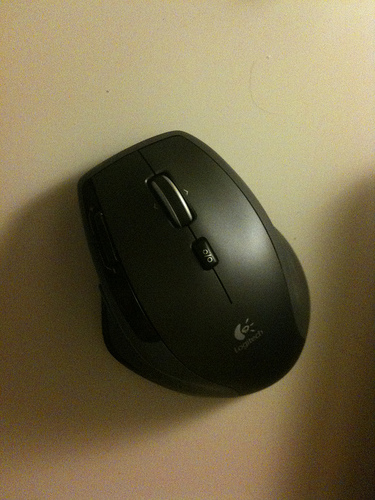<image>
Can you confirm if the mouse is under the desk? No. The mouse is not positioned under the desk. The vertical relationship between these objects is different. 